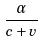<formula> <loc_0><loc_0><loc_500><loc_500>\frac { \alpha } { c + v }</formula> 